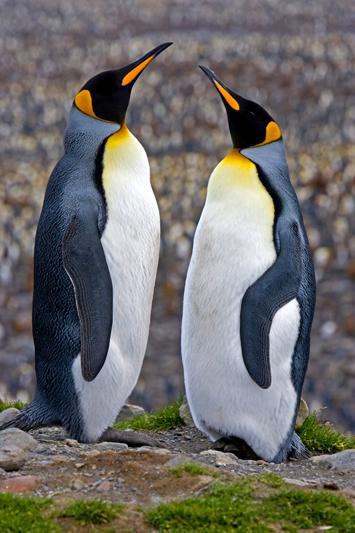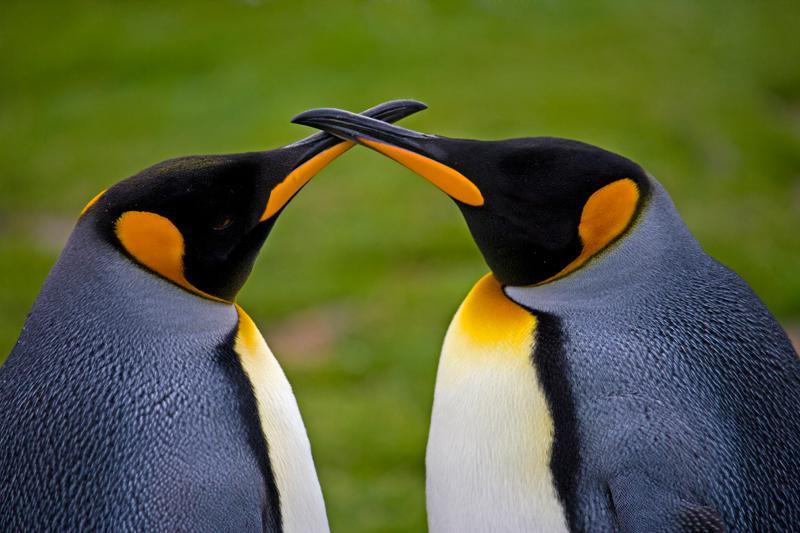The first image is the image on the left, the second image is the image on the right. Examine the images to the left and right. Is the description "There are four penguins in total." accurate? Answer yes or no. Yes. The first image is the image on the left, the second image is the image on the right. For the images displayed, is the sentence "At least one image contains at least five penguins." factually correct? Answer yes or no. No. The first image is the image on the left, the second image is the image on the right. Analyze the images presented: Is the assertion "Each image shows exactly two penguins posed close together." valid? Answer yes or no. Yes. 